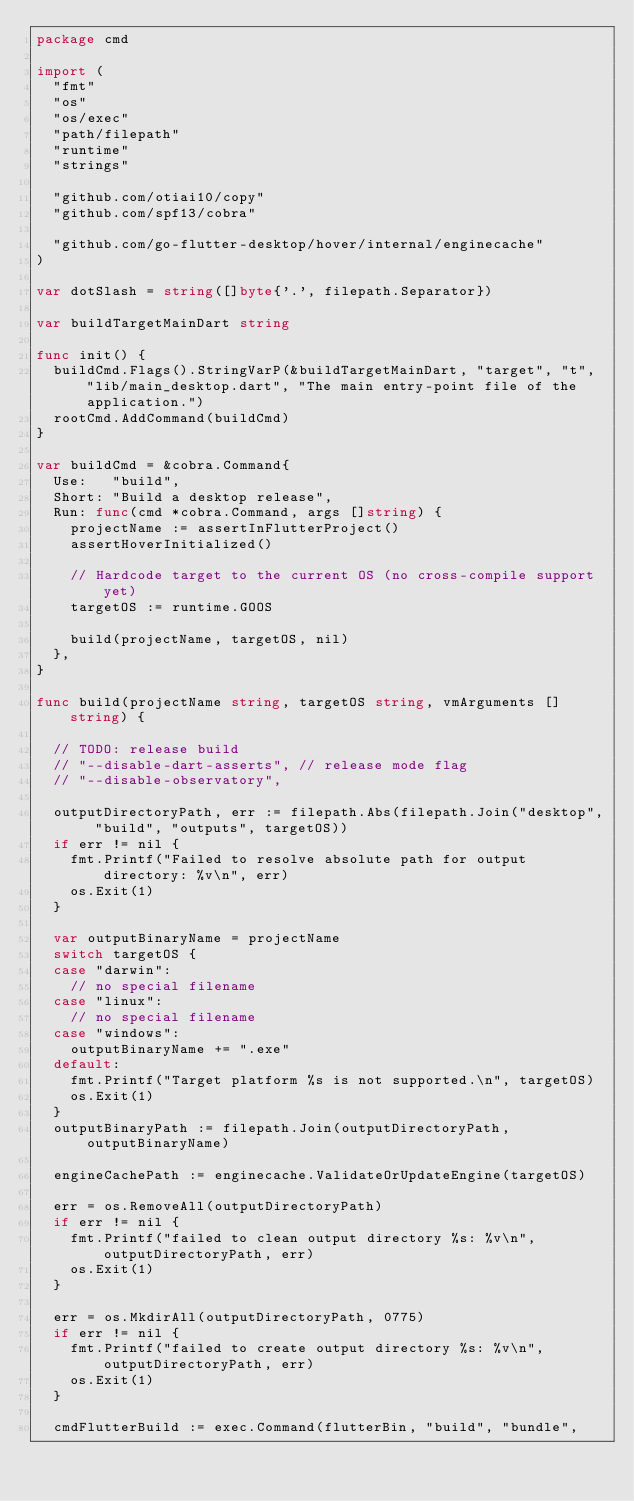Convert code to text. <code><loc_0><loc_0><loc_500><loc_500><_Go_>package cmd

import (
	"fmt"
	"os"
	"os/exec"
	"path/filepath"
	"runtime"
	"strings"

	"github.com/otiai10/copy"
	"github.com/spf13/cobra"

	"github.com/go-flutter-desktop/hover/internal/enginecache"
)

var dotSlash = string([]byte{'.', filepath.Separator})

var buildTargetMainDart string

func init() {
	buildCmd.Flags().StringVarP(&buildTargetMainDart, "target", "t", "lib/main_desktop.dart", "The main entry-point file of the application.")
	rootCmd.AddCommand(buildCmd)
}

var buildCmd = &cobra.Command{
	Use:   "build",
	Short: "Build a desktop release",
	Run: func(cmd *cobra.Command, args []string) {
		projectName := assertInFlutterProject()
		assertHoverInitialized()

		// Hardcode target to the current OS (no cross-compile support yet)
		targetOS := runtime.GOOS

		build(projectName, targetOS, nil)
	},
}

func build(projectName string, targetOS string, vmArguments []string) {

	// TODO: release build
	// "--disable-dart-asserts", // release mode flag
	// "--disable-observatory",

	outputDirectoryPath, err := filepath.Abs(filepath.Join("desktop", "build", "outputs", targetOS))
	if err != nil {
		fmt.Printf("Failed to resolve absolute path for output directory: %v\n", err)
		os.Exit(1)
	}

	var outputBinaryName = projectName
	switch targetOS {
	case "darwin":
		// no special filename
	case "linux":
		// no special filename
	case "windows":
		outputBinaryName += ".exe"
	default:
		fmt.Printf("Target platform %s is not supported.\n", targetOS)
		os.Exit(1)
	}
	outputBinaryPath := filepath.Join(outputDirectoryPath, outputBinaryName)

	engineCachePath := enginecache.ValidateOrUpdateEngine(targetOS)

	err = os.RemoveAll(outputDirectoryPath)
	if err != nil {
		fmt.Printf("failed to clean output directory %s: %v\n", outputDirectoryPath, err)
		os.Exit(1)
	}

	err = os.MkdirAll(outputDirectoryPath, 0775)
	if err != nil {
		fmt.Printf("failed to create output directory %s: %v\n", outputDirectoryPath, err)
		os.Exit(1)
	}

	cmdFlutterBuild := exec.Command(flutterBin, "build", "bundle",</code> 